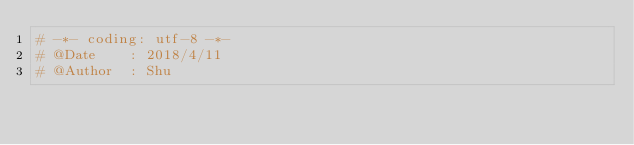Convert code to text. <code><loc_0><loc_0><loc_500><loc_500><_Python_># -*- coding: utf-8 -*-
# @Date    : 2018/4/11
# @Author  : Shu</code> 